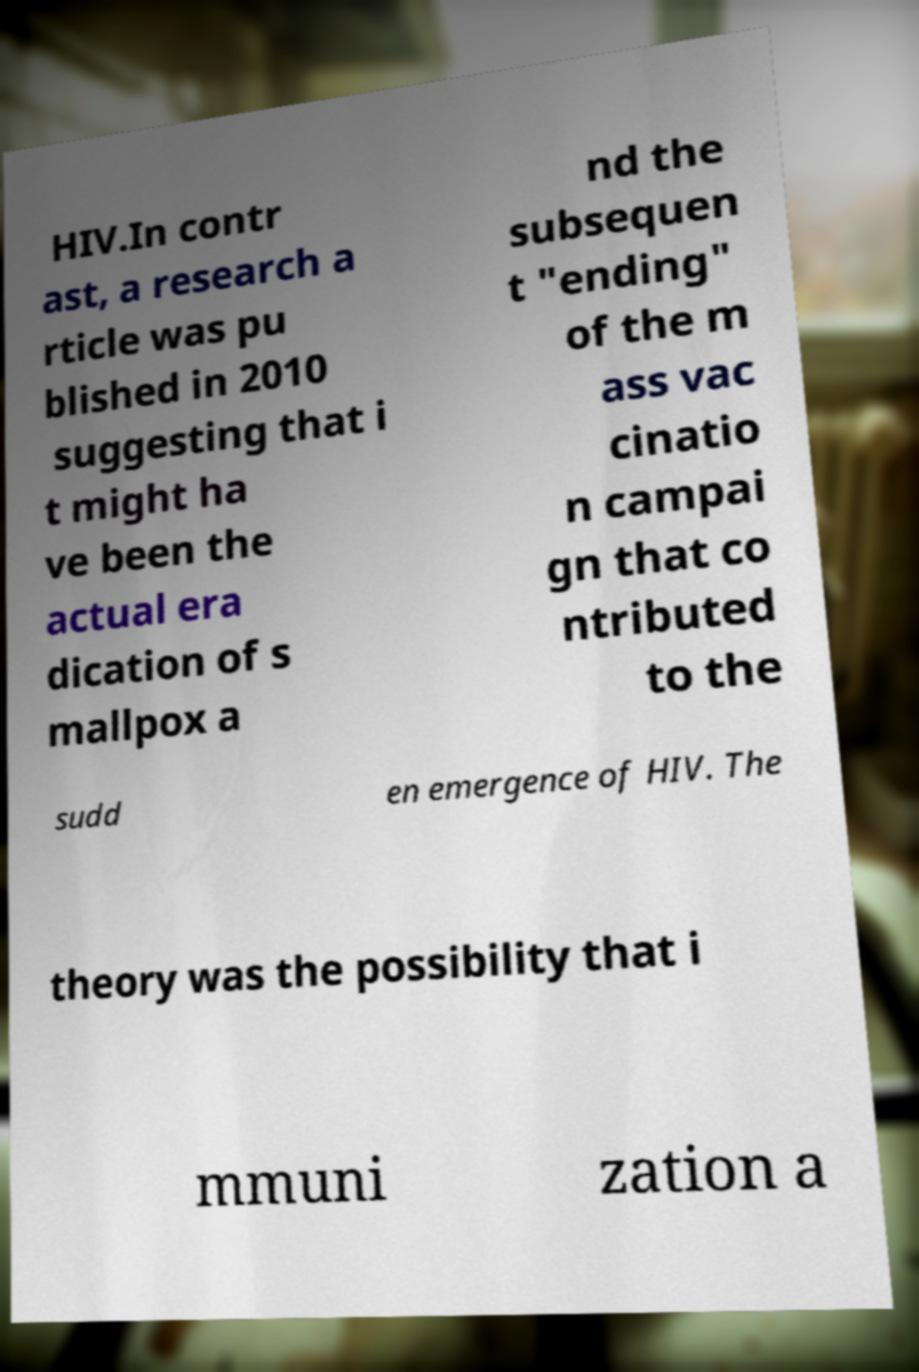Could you extract and type out the text from this image? HIV.In contr ast, a research a rticle was pu blished in 2010 suggesting that i t might ha ve been the actual era dication of s mallpox a nd the subsequen t "ending" of the m ass vac cinatio n campai gn that co ntributed to the sudd en emergence of HIV. The theory was the possibility that i mmuni zation a 